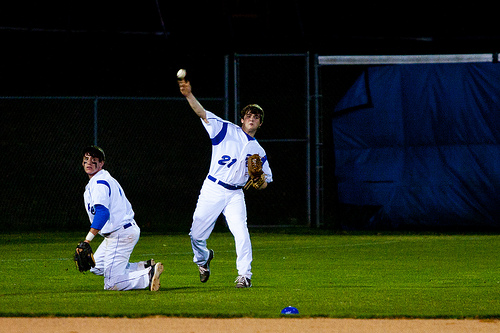Can you describe the setting and atmosphere of the game? The game is taking place under artificial lighting, indicative of a nighttime setting, which adds a dramatic touch to the scene. The intensity of the players is palpable, suggesting a crucial moment in the match. 